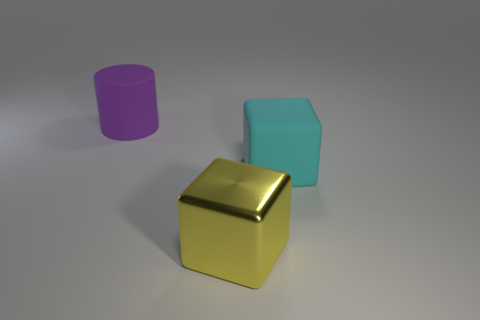What time of day do you think this photo represents based on the lighting? The lighting in the image seems diffuse and nondirectional, which makes it difficult to determine a specific time of day. It appears more consistent with artificial lighting that could be found indoors at any time. 